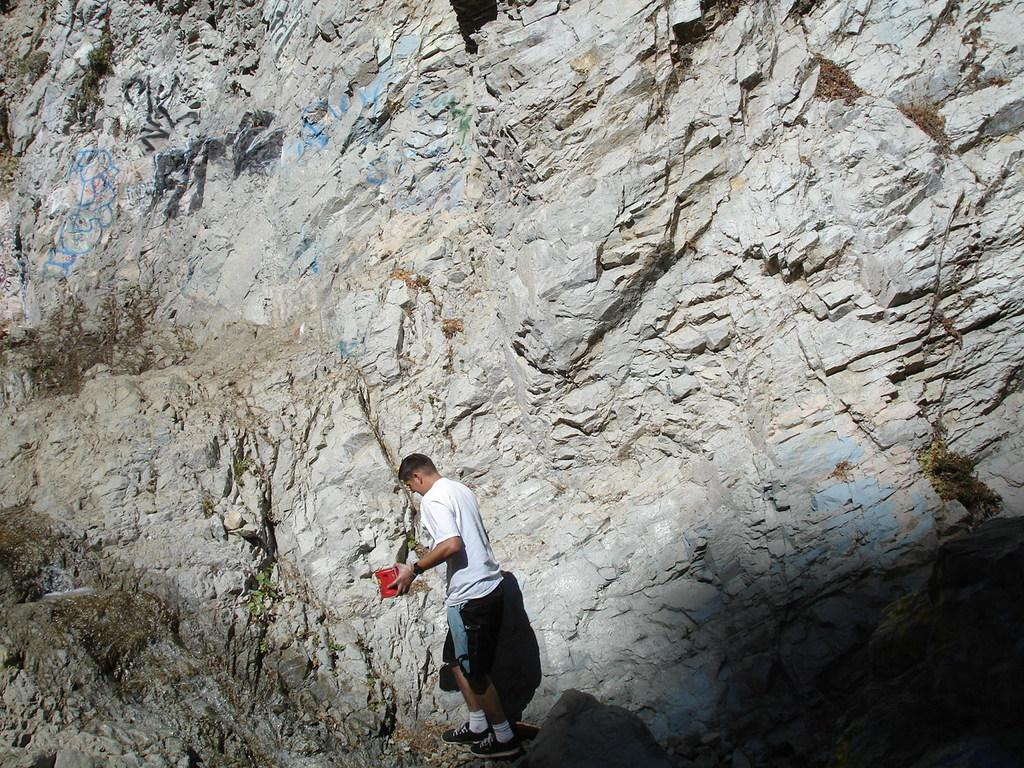What type of terrain is visible in the picture? There is a rocky hill in the picture. Is there anyone in the picture? Yes, there is a man standing near the hill. What is the man wearing? The man is wearing a white T-shirt. What is the man holding in the picture? The man is holding a red box. Can you tell me how much credit the man has in the image? There is no information about the man's credit in the image. What type of squirrel can be seen climbing the rocky hill in the image? There are no squirrels visible in the image; it only features a man standing near the hill. 